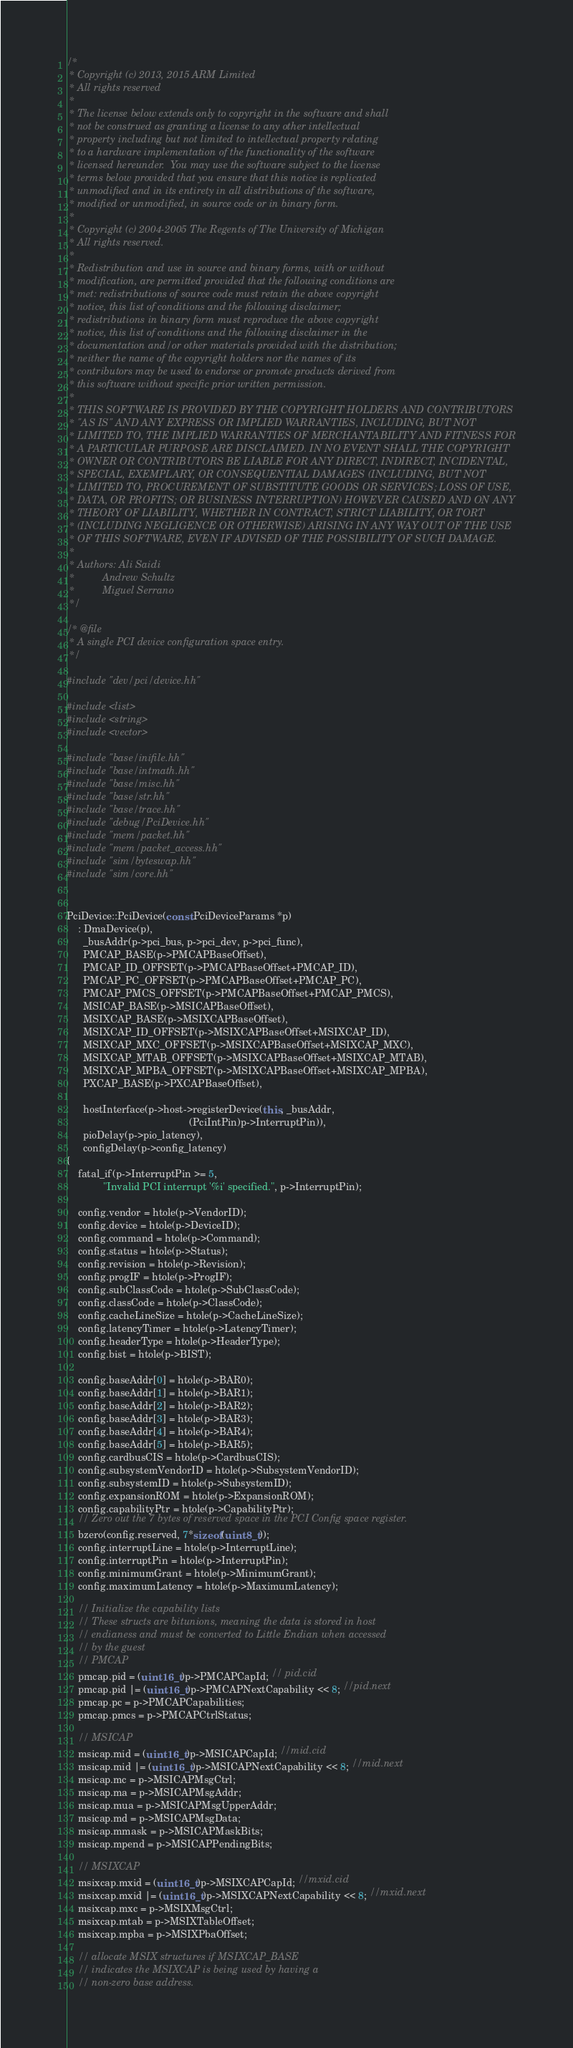<code> <loc_0><loc_0><loc_500><loc_500><_C++_>/*
 * Copyright (c) 2013, 2015 ARM Limited
 * All rights reserved
 *
 * The license below extends only to copyright in the software and shall
 * not be construed as granting a license to any other intellectual
 * property including but not limited to intellectual property relating
 * to a hardware implementation of the functionality of the software
 * licensed hereunder.  You may use the software subject to the license
 * terms below provided that you ensure that this notice is replicated
 * unmodified and in its entirety in all distributions of the software,
 * modified or unmodified, in source code or in binary form.
 *
 * Copyright (c) 2004-2005 The Regents of The University of Michigan
 * All rights reserved.
 *
 * Redistribution and use in source and binary forms, with or without
 * modification, are permitted provided that the following conditions are
 * met: redistributions of source code must retain the above copyright
 * notice, this list of conditions and the following disclaimer;
 * redistributions in binary form must reproduce the above copyright
 * notice, this list of conditions and the following disclaimer in the
 * documentation and/or other materials provided with the distribution;
 * neither the name of the copyright holders nor the names of its
 * contributors may be used to endorse or promote products derived from
 * this software without specific prior written permission.
 *
 * THIS SOFTWARE IS PROVIDED BY THE COPYRIGHT HOLDERS AND CONTRIBUTORS
 * "AS IS" AND ANY EXPRESS OR IMPLIED WARRANTIES, INCLUDING, BUT NOT
 * LIMITED TO, THE IMPLIED WARRANTIES OF MERCHANTABILITY AND FITNESS FOR
 * A PARTICULAR PURPOSE ARE DISCLAIMED. IN NO EVENT SHALL THE COPYRIGHT
 * OWNER OR CONTRIBUTORS BE LIABLE FOR ANY DIRECT, INDIRECT, INCIDENTAL,
 * SPECIAL, EXEMPLARY, OR CONSEQUENTIAL DAMAGES (INCLUDING, BUT NOT
 * LIMITED TO, PROCUREMENT OF SUBSTITUTE GOODS OR SERVICES; LOSS OF USE,
 * DATA, OR PROFITS; OR BUSINESS INTERRUPTION) HOWEVER CAUSED AND ON ANY
 * THEORY OF LIABILITY, WHETHER IN CONTRACT, STRICT LIABILITY, OR TORT
 * (INCLUDING NEGLIGENCE OR OTHERWISE) ARISING IN ANY WAY OUT OF THE USE
 * OF THIS SOFTWARE, EVEN IF ADVISED OF THE POSSIBILITY OF SUCH DAMAGE.
 *
 * Authors: Ali Saidi
 *          Andrew Schultz
 *          Miguel Serrano
 */

/* @file
 * A single PCI device configuration space entry.
 */

#include "dev/pci/device.hh"

#include <list>
#include <string>
#include <vector>

#include "base/inifile.hh"
#include "base/intmath.hh"
#include "base/misc.hh"
#include "base/str.hh"
#include "base/trace.hh"
#include "debug/PciDevice.hh"
#include "mem/packet.hh"
#include "mem/packet_access.hh"
#include "sim/byteswap.hh"
#include "sim/core.hh"


PciDevice::PciDevice(const PciDeviceParams *p)
    : DmaDevice(p),
      _busAddr(p->pci_bus, p->pci_dev, p->pci_func),
      PMCAP_BASE(p->PMCAPBaseOffset),
      PMCAP_ID_OFFSET(p->PMCAPBaseOffset+PMCAP_ID),
      PMCAP_PC_OFFSET(p->PMCAPBaseOffset+PMCAP_PC),
      PMCAP_PMCS_OFFSET(p->PMCAPBaseOffset+PMCAP_PMCS),
      MSICAP_BASE(p->MSICAPBaseOffset),
      MSIXCAP_BASE(p->MSIXCAPBaseOffset),
      MSIXCAP_ID_OFFSET(p->MSIXCAPBaseOffset+MSIXCAP_ID),
      MSIXCAP_MXC_OFFSET(p->MSIXCAPBaseOffset+MSIXCAP_MXC),
      MSIXCAP_MTAB_OFFSET(p->MSIXCAPBaseOffset+MSIXCAP_MTAB),
      MSIXCAP_MPBA_OFFSET(p->MSIXCAPBaseOffset+MSIXCAP_MPBA),
      PXCAP_BASE(p->PXCAPBaseOffset),

      hostInterface(p->host->registerDevice(this, _busAddr,
                                            (PciIntPin)p->InterruptPin)),
      pioDelay(p->pio_latency),
      configDelay(p->config_latency)
{
    fatal_if(p->InterruptPin >= 5,
             "Invalid PCI interrupt '%i' specified.", p->InterruptPin);

    config.vendor = htole(p->VendorID);
    config.device = htole(p->DeviceID);
    config.command = htole(p->Command);
    config.status = htole(p->Status);
    config.revision = htole(p->Revision);
    config.progIF = htole(p->ProgIF);
    config.subClassCode = htole(p->SubClassCode);
    config.classCode = htole(p->ClassCode);
    config.cacheLineSize = htole(p->CacheLineSize);
    config.latencyTimer = htole(p->LatencyTimer);
    config.headerType = htole(p->HeaderType);
    config.bist = htole(p->BIST);

    config.baseAddr[0] = htole(p->BAR0);
    config.baseAddr[1] = htole(p->BAR1);
    config.baseAddr[2] = htole(p->BAR2);
    config.baseAddr[3] = htole(p->BAR3);
    config.baseAddr[4] = htole(p->BAR4);
    config.baseAddr[5] = htole(p->BAR5);
    config.cardbusCIS = htole(p->CardbusCIS);
    config.subsystemVendorID = htole(p->SubsystemVendorID);
    config.subsystemID = htole(p->SubsystemID);
    config.expansionROM = htole(p->ExpansionROM);
    config.capabilityPtr = htole(p->CapabilityPtr);
    // Zero out the 7 bytes of reserved space in the PCI Config space register.
    bzero(config.reserved, 7*sizeof(uint8_t));
    config.interruptLine = htole(p->InterruptLine);
    config.interruptPin = htole(p->InterruptPin);
    config.minimumGrant = htole(p->MinimumGrant);
    config.maximumLatency = htole(p->MaximumLatency);

    // Initialize the capability lists
    // These structs are bitunions, meaning the data is stored in host
    // endianess and must be converted to Little Endian when accessed
    // by the guest
    // PMCAP
    pmcap.pid = (uint16_t)p->PMCAPCapId; // pid.cid
    pmcap.pid |= (uint16_t)p->PMCAPNextCapability << 8; //pid.next
    pmcap.pc = p->PMCAPCapabilities;
    pmcap.pmcs = p->PMCAPCtrlStatus;

    // MSICAP
    msicap.mid = (uint16_t)p->MSICAPCapId; //mid.cid
    msicap.mid |= (uint16_t)p->MSICAPNextCapability << 8; //mid.next
    msicap.mc = p->MSICAPMsgCtrl;
    msicap.ma = p->MSICAPMsgAddr;
    msicap.mua = p->MSICAPMsgUpperAddr;
    msicap.md = p->MSICAPMsgData;
    msicap.mmask = p->MSICAPMaskBits;
    msicap.mpend = p->MSICAPPendingBits;

    // MSIXCAP
    msixcap.mxid = (uint16_t)p->MSIXCAPCapId; //mxid.cid
    msixcap.mxid |= (uint16_t)p->MSIXCAPNextCapability << 8; //mxid.next
    msixcap.mxc = p->MSIXMsgCtrl;
    msixcap.mtab = p->MSIXTableOffset;
    msixcap.mpba = p->MSIXPbaOffset;

    // allocate MSIX structures if MSIXCAP_BASE
    // indicates the MSIXCAP is being used by having a
    // non-zero base address.</code> 